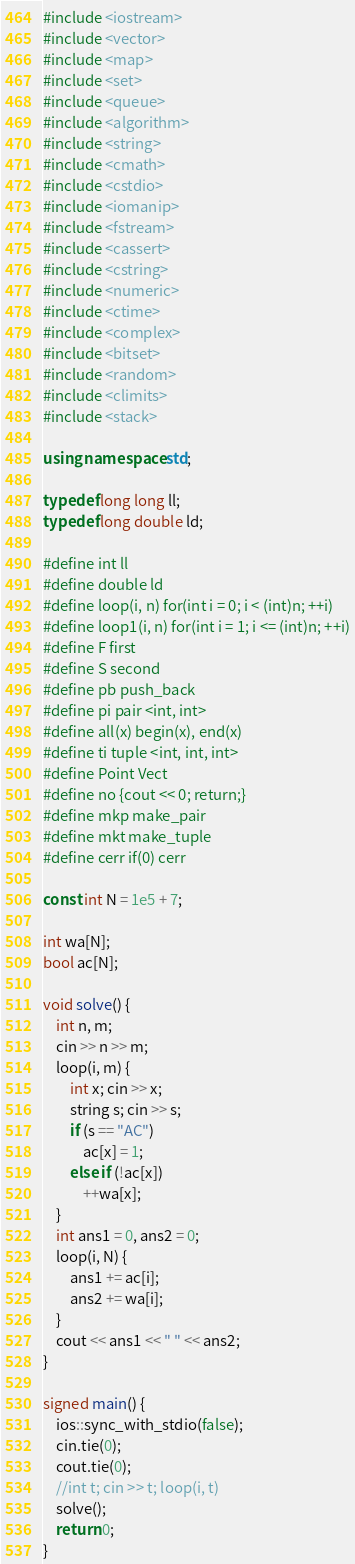Convert code to text. <code><loc_0><loc_0><loc_500><loc_500><_C++_>#include <iostream>
#include <vector>
#include <map>
#include <set>
#include <queue>
#include <algorithm>
#include <string>
#include <cmath>
#include <cstdio>
#include <iomanip>
#include <fstream>
#include <cassert>
#include <cstring>
#include <numeric>
#include <ctime>
#include <complex>
#include <bitset>
#include <random>
#include <climits>
#include <stack>

using namespace std;

typedef long long ll;
typedef long double ld;

#define int ll
#define double ld
#define loop(i, n) for(int i = 0; i < (int)n; ++i)
#define loop1(i, n) for(int i = 1; i <= (int)n; ++i)
#define F first
#define S second
#define pb push_back
#define pi pair <int, int>
#define all(x) begin(x), end(x)
#define ti tuple <int, int, int>
#define Point Vect
#define no {cout << 0; return;}
#define mkp make_pair
#define mkt make_tuple
#define cerr if(0) cerr

const int N = 1e5 + 7;

int wa[N];
bool ac[N];

void solve() {
    int n, m;
    cin >> n >> m;
    loop(i, m) {
        int x; cin >> x;
        string s; cin >> s;
        if (s == "AC")
            ac[x] = 1;
        else if (!ac[x])
            ++wa[x];
    }
    int ans1 = 0, ans2 = 0;
    loop(i, N) {
        ans1 += ac[i];
        ans2 += wa[i];
    }
    cout << ans1 << " " << ans2;
}

signed main() {
    ios::sync_with_stdio(false);
    cin.tie(0);
    cout.tie(0);
    //int t; cin >> t; loop(i, t)
    solve();
    return 0;
}</code> 